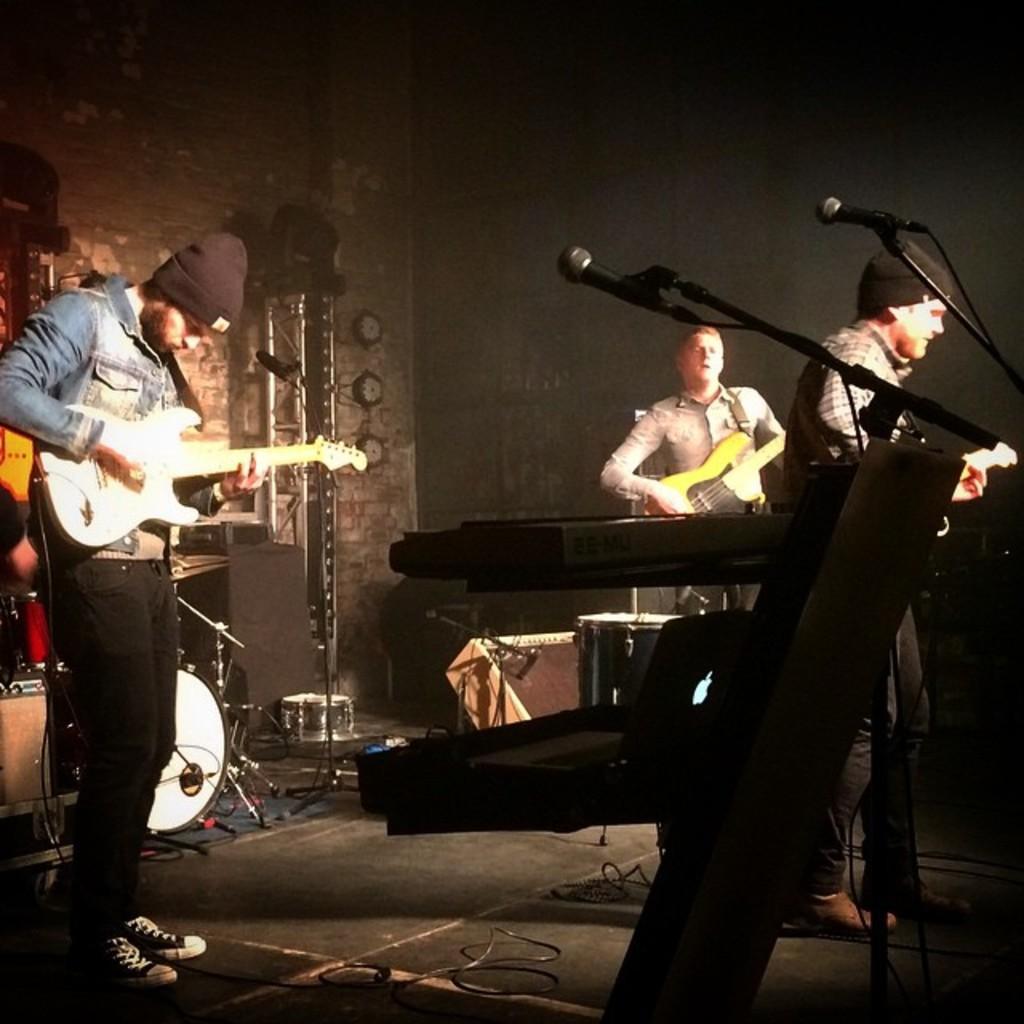In one or two sentences, can you explain what this image depicts? In the left, a person is standing and playing a guitar. In the right two persons are standing and playing a guitar in front of the mike. Beside that the keyboard is kept. And on the stage some musical instruments are there. The background wall is dark and brown in color. This image is taken inside a hall. 